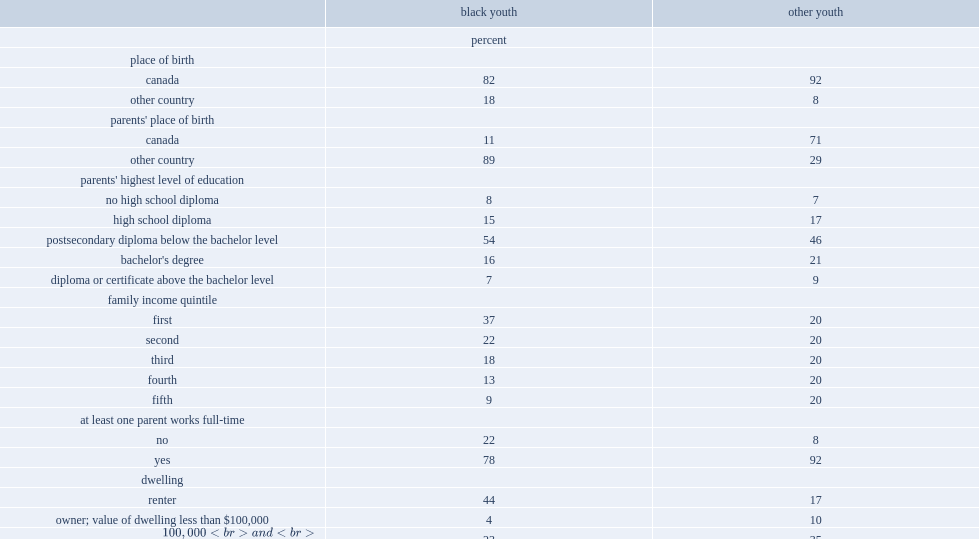What were the percentages of black youth and other youth who lived with a parent whose highest level of education was a university degree respectively? 23 30. Who were more likely to live in economically disadvantaged families in 2006,black youth or other youth? Black youth. What was the multiple relationship between black youth and other youth who lived in the bottom quintile of family income? 1.85. Who were less likely to live in a dwelling owned by a household member. Black youth. What were the percentages of black youth and other youth who lived with only one parent in 2006 respectively? 45.0 17.0. What were the percentages of black youth and other youth who were born in canada respectively? 82.0 92.0. Who had a higher proportion for an immigrant background,meaning that they had parents born outside canada,black youth or other youth? Black youth. 